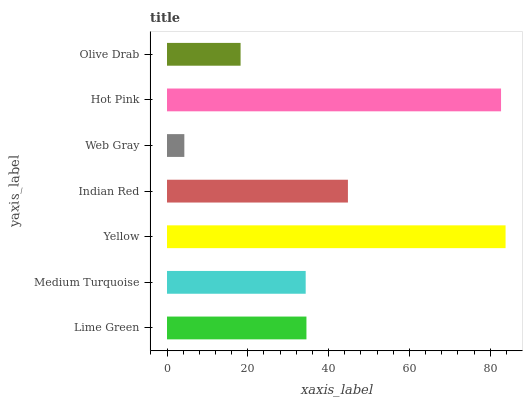Is Web Gray the minimum?
Answer yes or no. Yes. Is Yellow the maximum?
Answer yes or no. Yes. Is Medium Turquoise the minimum?
Answer yes or no. No. Is Medium Turquoise the maximum?
Answer yes or no. No. Is Lime Green greater than Medium Turquoise?
Answer yes or no. Yes. Is Medium Turquoise less than Lime Green?
Answer yes or no. Yes. Is Medium Turquoise greater than Lime Green?
Answer yes or no. No. Is Lime Green less than Medium Turquoise?
Answer yes or no. No. Is Lime Green the high median?
Answer yes or no. Yes. Is Lime Green the low median?
Answer yes or no. Yes. Is Indian Red the high median?
Answer yes or no. No. Is Indian Red the low median?
Answer yes or no. No. 